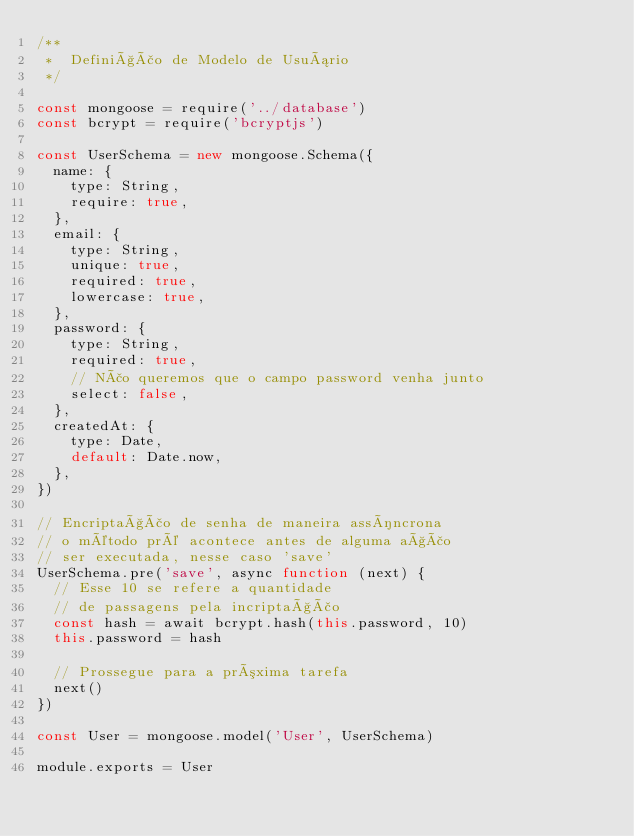Convert code to text. <code><loc_0><loc_0><loc_500><loc_500><_JavaScript_>/**
 *  Definição de Modelo de Usuário
 */

const mongoose = require('../database')
const bcrypt = require('bcryptjs')

const UserSchema = new mongoose.Schema({
  name: {
    type: String,
    require: true,
  },
  email: {
    type: String,
    unique: true,
    required: true,
    lowercase: true,
  },
  password: {
    type: String,
    required: true,
    // Não queremos que o campo password venha junto
    select: false,
  },
  createdAt: {
    type: Date,
    default: Date.now,
  },
})

// Encriptação de senha de maneira assíncrona
// o método pré acontece antes de alguma ação
// ser executada, nesse caso 'save'
UserSchema.pre('save', async function (next) {
  // Esse 10 se refere a quantidade
  // de passagens pela incriptação
  const hash = await bcrypt.hash(this.password, 10)
  this.password = hash

  // Prossegue para a próxima tarefa
  next()
})

const User = mongoose.model('User', UserSchema)

module.exports = User
</code> 